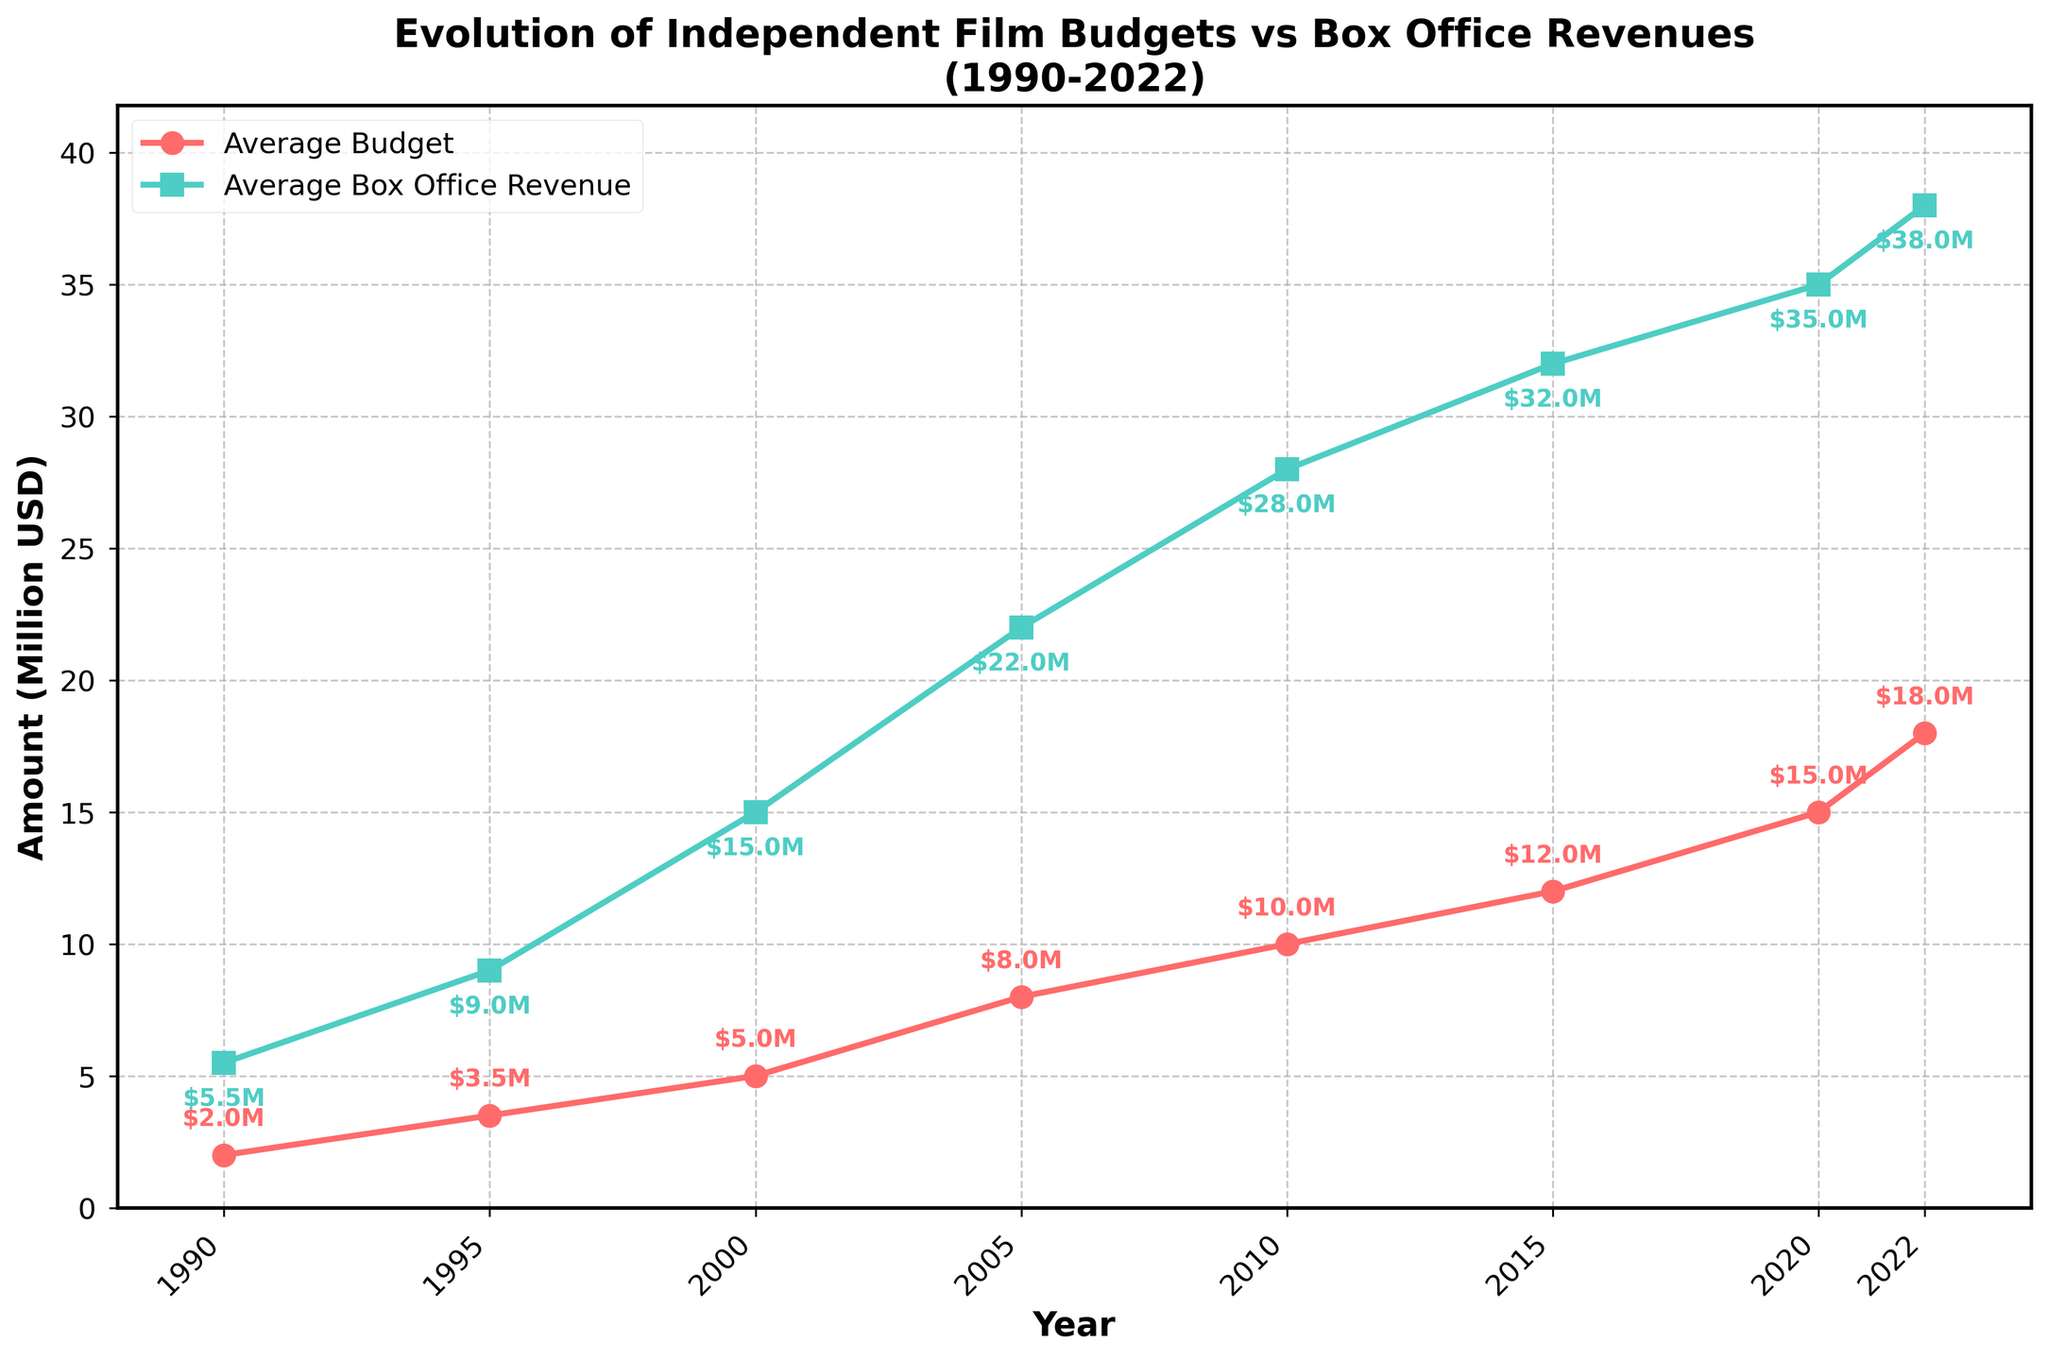What is the average budget of independent films in 2010? The figure shows the average budgets as annotations. For 2010, it's shown as $10.0M.
Answer: $10.0M Compare the average box office revenue between 1995 and 2020. Which year had a higher revenue? According to the graph, 1995 has a box office revenue of $9.0M, while 2020 has a revenue of $35.0M. 2020 has a higher revenue.
Answer: 2020 By how much did the average independent film budget increase from 1990 to 2022? In 1990, the average budget is $2.0M, and in 2022 it is $18.0M. The increase is $18.0M - $2.0M = $16.0M.
Answer: $16.0M What's the difference between the average box office revenue and the average budget in 2005? The average budget in 2005 is $8.0M, and the average box office revenue is $22.0M. The difference is $22.0M - $8.0M = $14.0M.
Answer: $14.0M What trend do you observe in the average box office revenue from 1990 to 2022? The average box office revenue shows a generally increasing trend from $5.5M in 1990 to $38.0M in 2022.
Answer: Increasing How much higher is the box office revenue compared to the film budget in 2015? The box office revenue in 2015 is $32.0M, and the budget is $12.0M. The difference is $32.0M - $12.0M = $20.0M.
Answer: $20.0M Describe the visual differences in the markers used for average budget and box office revenue lines. The average budget line uses circular markers (o) colored red, while the average box office revenue line uses square markers (s) colored green.
Answer: Circular red (budget), Square green (revenue) By how much did the average box office revenue increase from 2000 to 2010? In 2000, the average box office revenue is $15.0M, and in 2010 it is $28.0M. The increase is $28.0M - $15.0M = $13.0M.
Answer: $13.0M Which year has the smallest gap between average budget and box office revenue? By examining the vertical distance between the lines, 1990 has the smallest gap, where budget is $2.0M and box office revenue is $5.5M. The gap is $3.5M.
Answer: 1990 